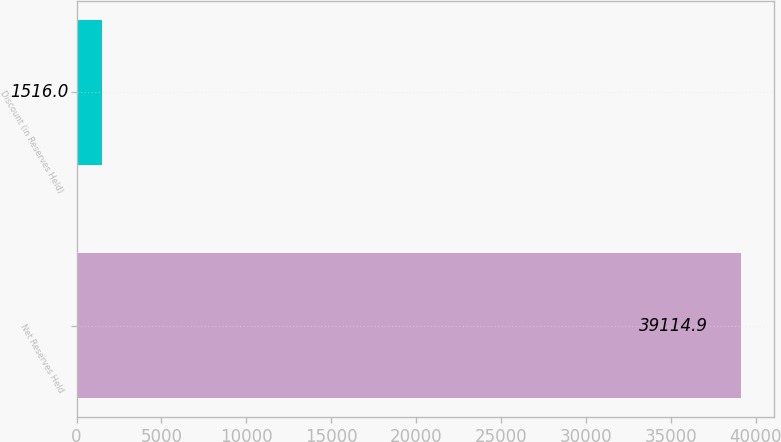Convert chart. <chart><loc_0><loc_0><loc_500><loc_500><bar_chart><fcel>Net Reserves Held<fcel>Discount (in Reserves Held)<nl><fcel>39114.9<fcel>1516<nl></chart> 